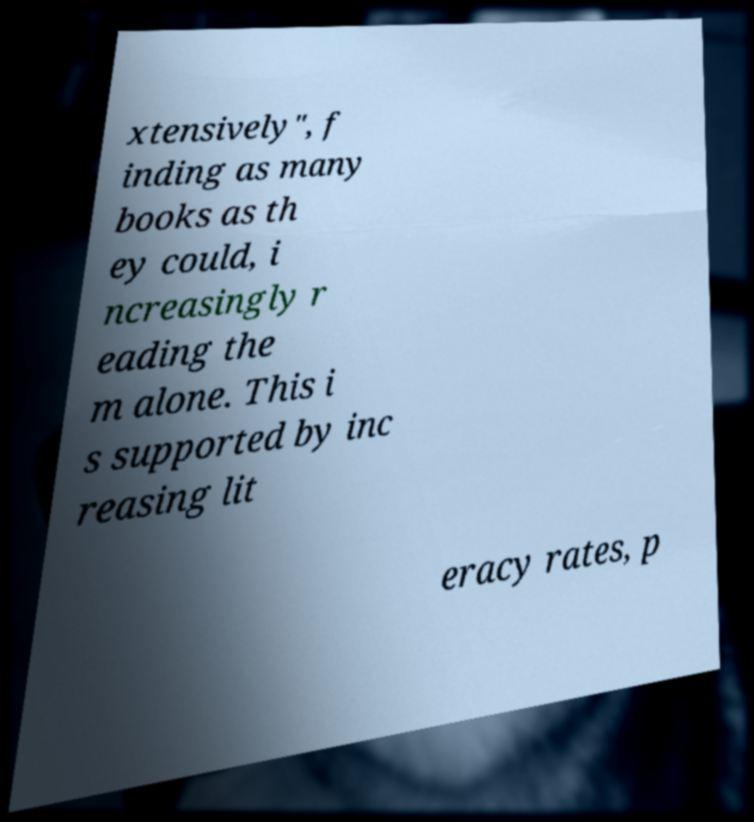Could you extract and type out the text from this image? xtensively", f inding as many books as th ey could, i ncreasingly r eading the m alone. This i s supported by inc reasing lit eracy rates, p 